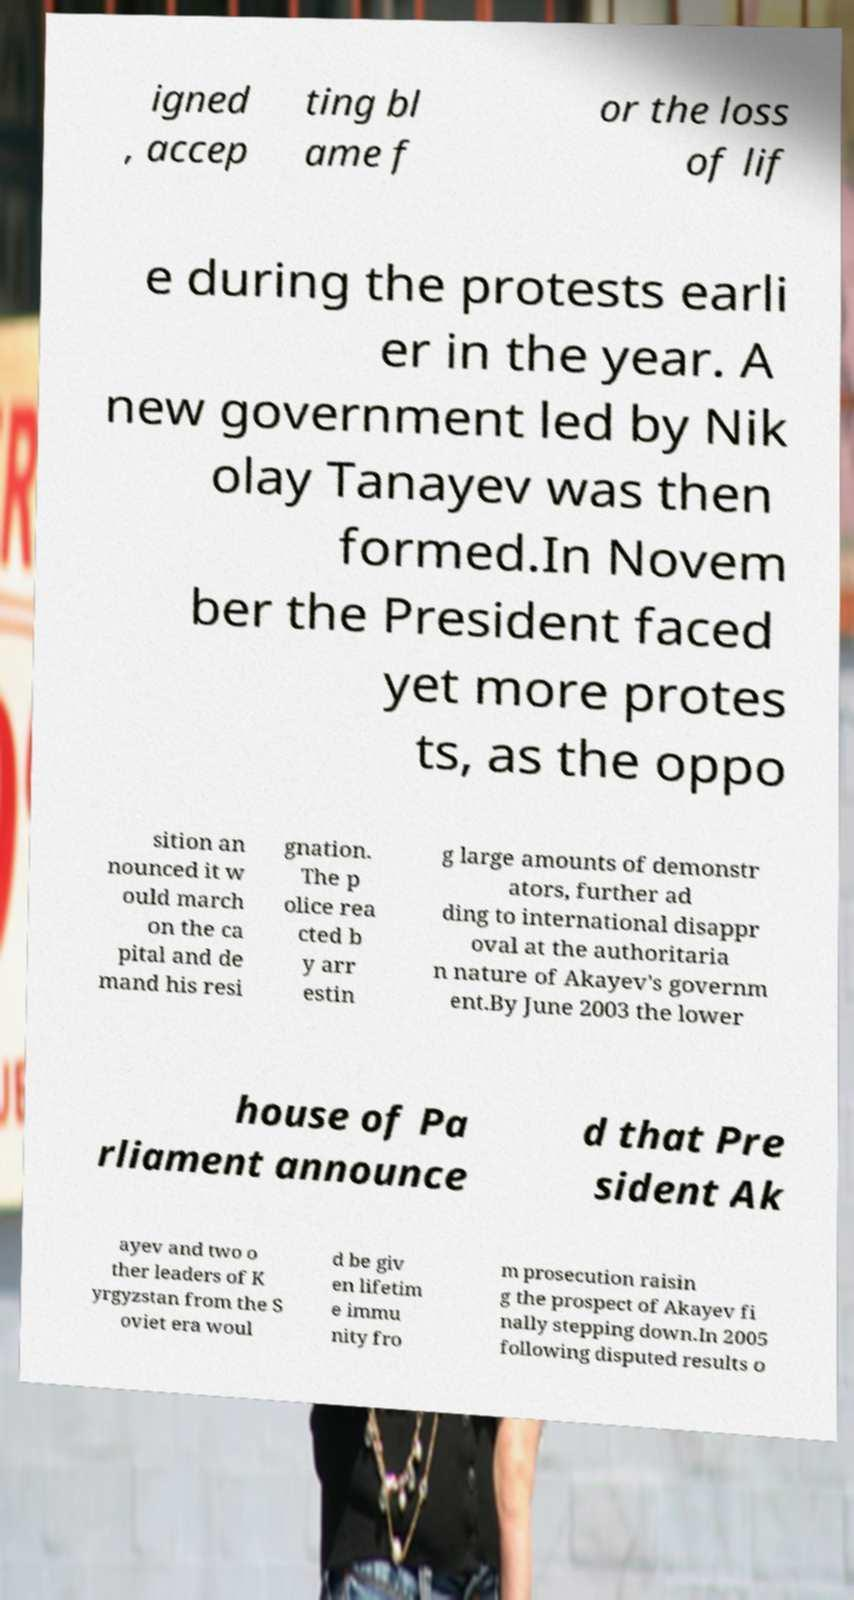Please read and relay the text visible in this image. What does it say? igned , accep ting bl ame f or the loss of lif e during the protests earli er in the year. A new government led by Nik olay Tanayev was then formed.In Novem ber the President faced yet more protes ts, as the oppo sition an nounced it w ould march on the ca pital and de mand his resi gnation. The p olice rea cted b y arr estin g large amounts of demonstr ators, further ad ding to international disappr oval at the authoritaria n nature of Akayev's governm ent.By June 2003 the lower house of Pa rliament announce d that Pre sident Ak ayev and two o ther leaders of K yrgyzstan from the S oviet era woul d be giv en lifetim e immu nity fro m prosecution raisin g the prospect of Akayev fi nally stepping down.In 2005 following disputed results o 